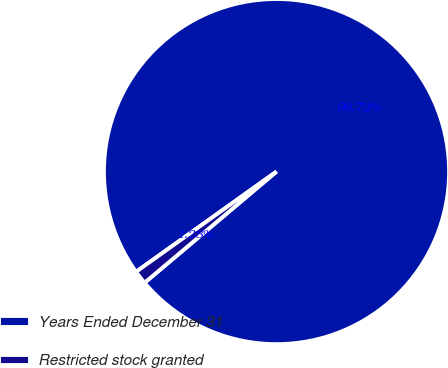<chart> <loc_0><loc_0><loc_500><loc_500><pie_chart><fcel>Years Ended December 31<fcel>Restricted stock granted<nl><fcel>98.72%<fcel>1.28%<nl></chart> 